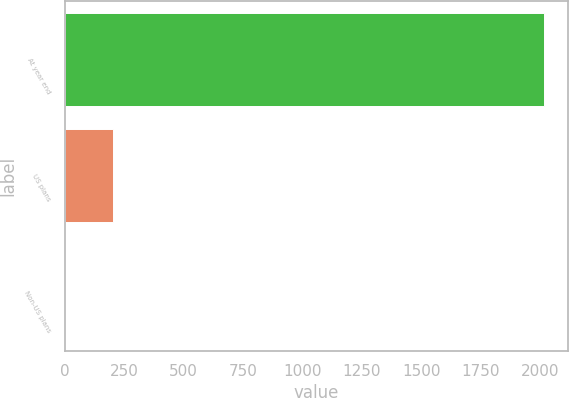Convert chart to OTSL. <chart><loc_0><loc_0><loc_500><loc_500><bar_chart><fcel>At year end<fcel>US plans<fcel>Non-US plans<nl><fcel>2016<fcel>203.18<fcel>1.75<nl></chart> 